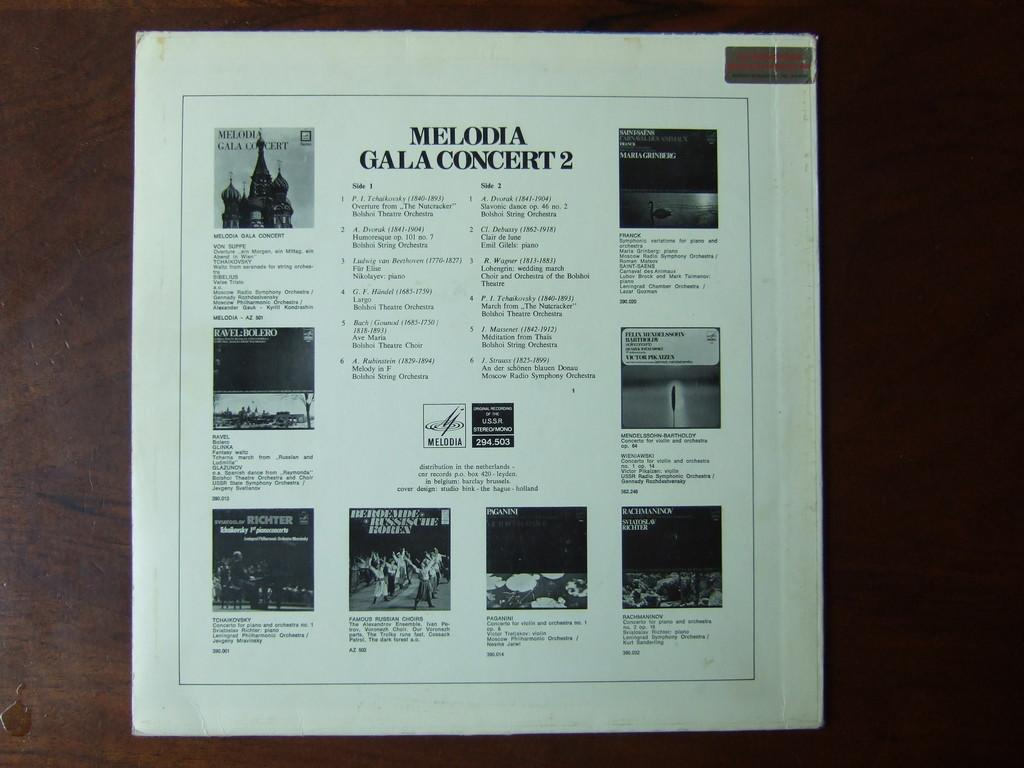<image>
Give a short and clear explanation of the subsequent image. The back side of the record Melodia Gala Concert 2 